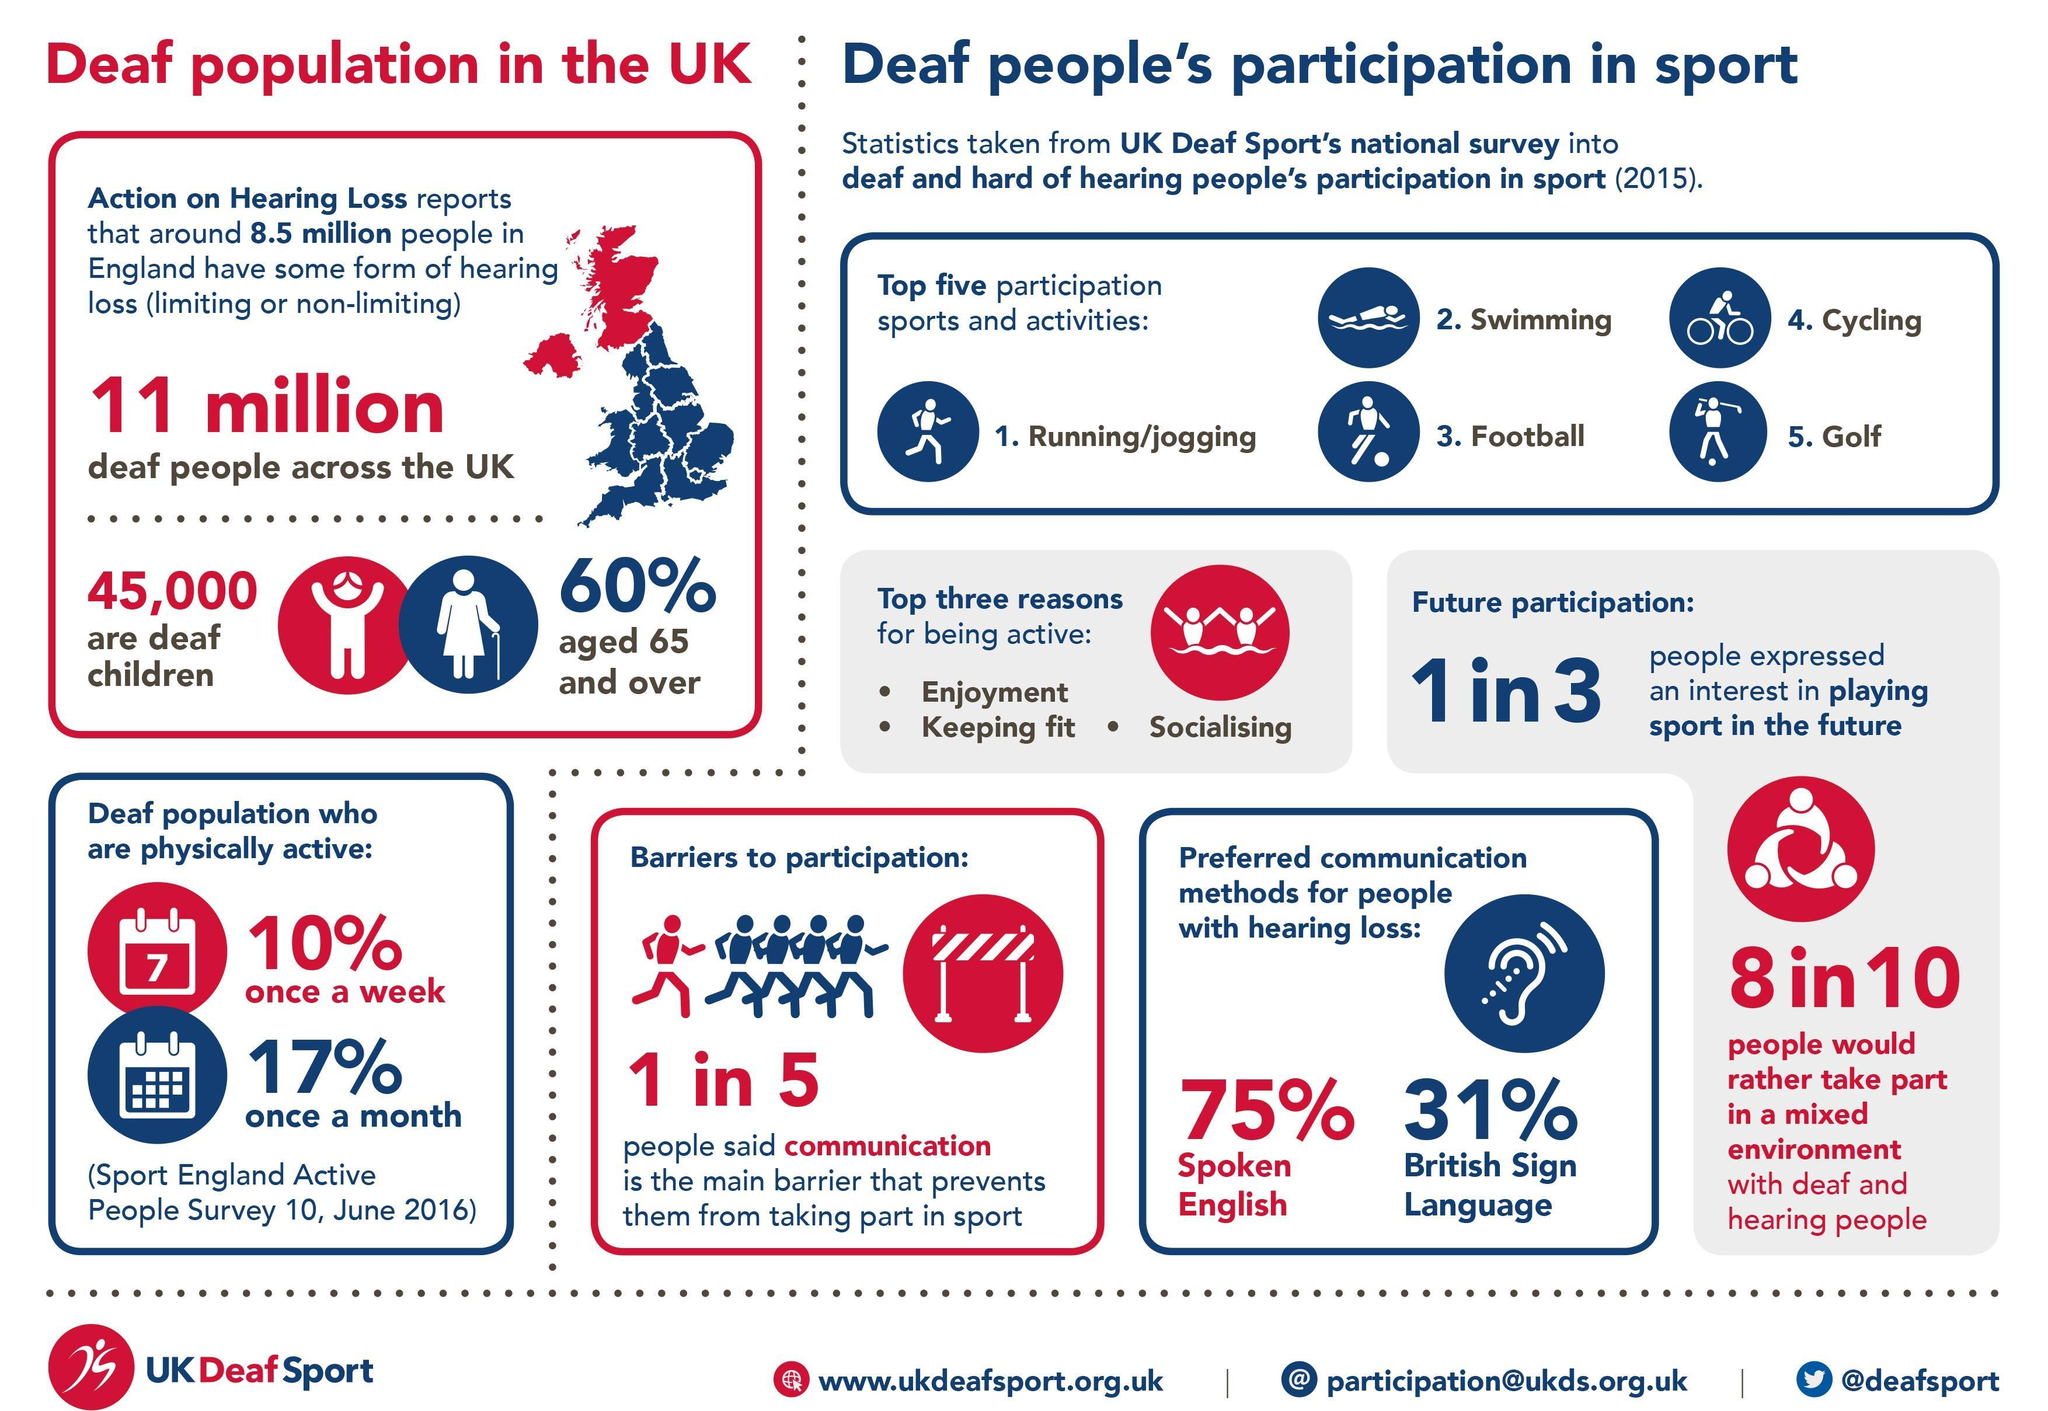For how many people, communication is not a barrier that prevents them from participating in sports?
Answer the question with a short phrase. 4 in 5 What percent of deaf people are senior citizens? 60% What are the benefits of activity according to the UK Deaf Sports national Survey? Enjoyment, Keeping fit, Socialising Out of 11 million deaf people across UK, what percent are children? 40% How many people did not express an interest in playing sport in the future? 2 in 3 How many people are not willing to take part in a mixed environment? 2 in 10 Which is the most common method adopted by deaf people to communicate?? Spoken English Which time is the deaf population physically active more- once a week or once a month? once a month 